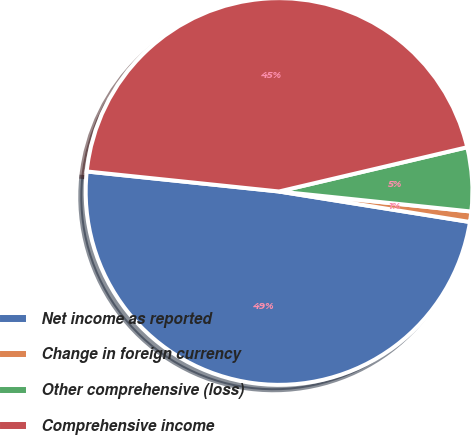Convert chart. <chart><loc_0><loc_0><loc_500><loc_500><pie_chart><fcel>Net income as reported<fcel>Change in foreign currency<fcel>Other comprehensive (loss)<fcel>Comprehensive income<nl><fcel>49.13%<fcel>0.87%<fcel>5.33%<fcel>44.67%<nl></chart> 